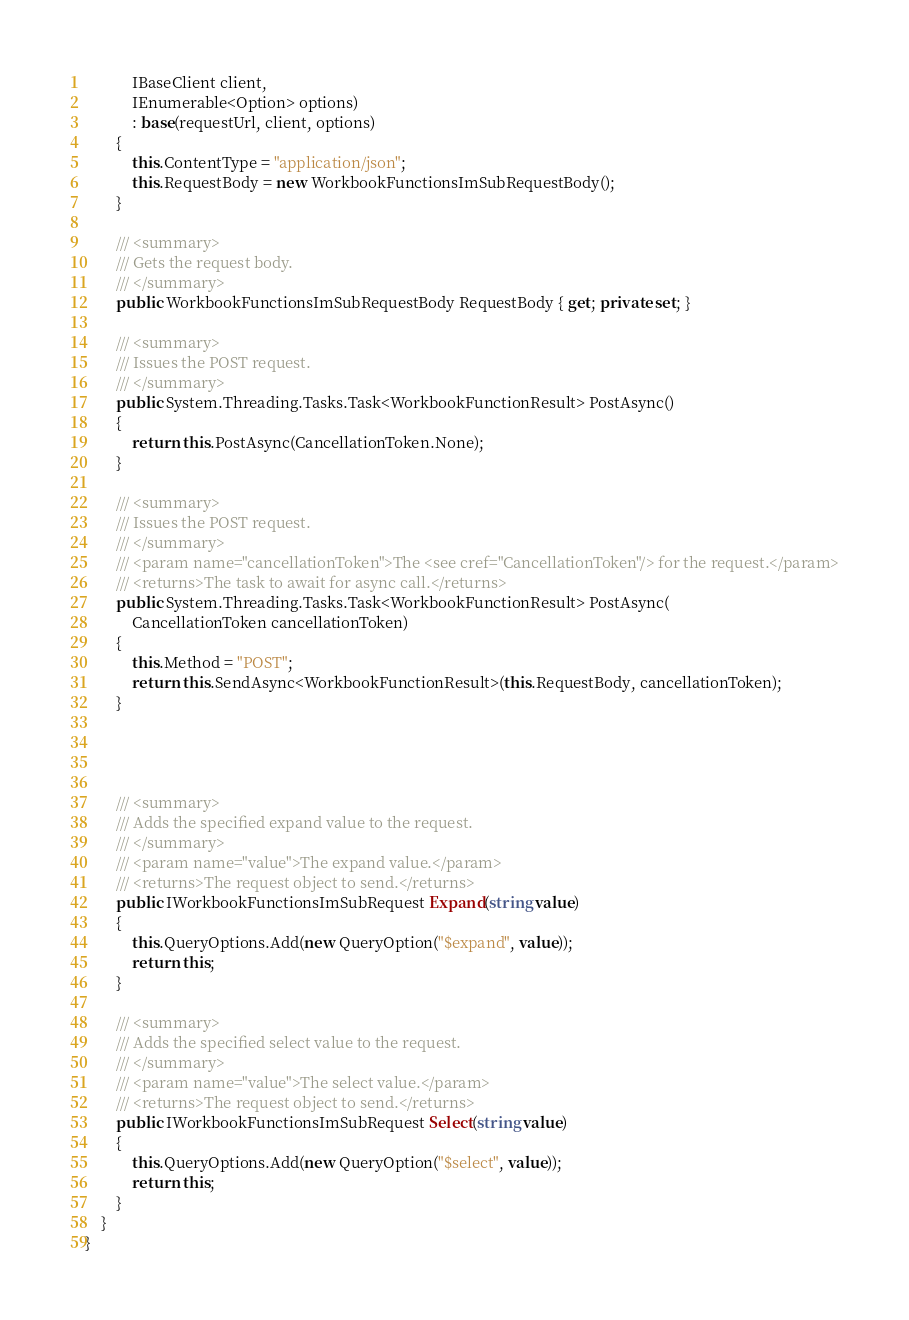Convert code to text. <code><loc_0><loc_0><loc_500><loc_500><_C#_>            IBaseClient client,
            IEnumerable<Option> options)
            : base(requestUrl, client, options)
        {
            this.ContentType = "application/json";
            this.RequestBody = new WorkbookFunctionsImSubRequestBody();
        }

        /// <summary>
        /// Gets the request body.
        /// </summary>
        public WorkbookFunctionsImSubRequestBody RequestBody { get; private set; }

        /// <summary>
        /// Issues the POST request.
        /// </summary>
        public System.Threading.Tasks.Task<WorkbookFunctionResult> PostAsync()
        {
            return this.PostAsync(CancellationToken.None);
        }

        /// <summary>
        /// Issues the POST request.
        /// </summary>
        /// <param name="cancellationToken">The <see cref="CancellationToken"/> for the request.</param>
        /// <returns>The task to await for async call.</returns>
        public System.Threading.Tasks.Task<WorkbookFunctionResult> PostAsync(
            CancellationToken cancellationToken)
        {
            this.Method = "POST";
            return this.SendAsync<WorkbookFunctionResult>(this.RequestBody, cancellationToken);
        }




        /// <summary>
        /// Adds the specified expand value to the request.
        /// </summary>
        /// <param name="value">The expand value.</param>
        /// <returns>The request object to send.</returns>
        public IWorkbookFunctionsImSubRequest Expand(string value)
        {
            this.QueryOptions.Add(new QueryOption("$expand", value));
            return this;
        }

        /// <summary>
        /// Adds the specified select value to the request.
        /// </summary>
        /// <param name="value">The select value.</param>
        /// <returns>The request object to send.</returns>
        public IWorkbookFunctionsImSubRequest Select(string value)
        {
            this.QueryOptions.Add(new QueryOption("$select", value));
            return this;
        }
    }
}
</code> 